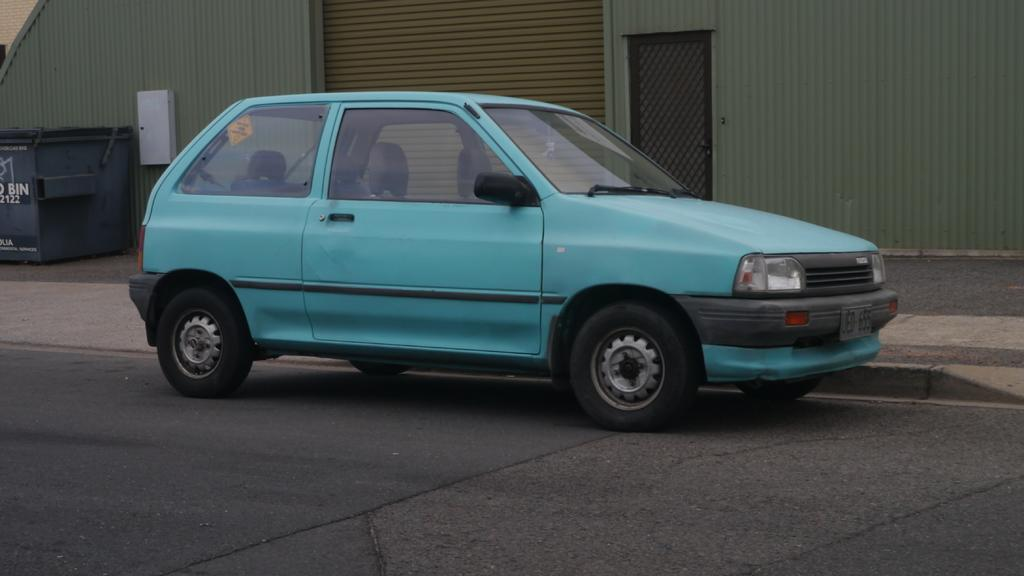What is the main subject of the image? The main subject of the image is a car. Where is the car located in the image? The car is placed on the road. What can be seen in the background of the image? There is a door, a shed, and a bin in the background of the image. What type of scarf is being advertised on the car in the image? There is no scarf or advertisement present on the car in the image. How many pins are holding the door open in the background of the image? There are no pins visible in the image, and the door's status (open or closed) cannot be determined. 